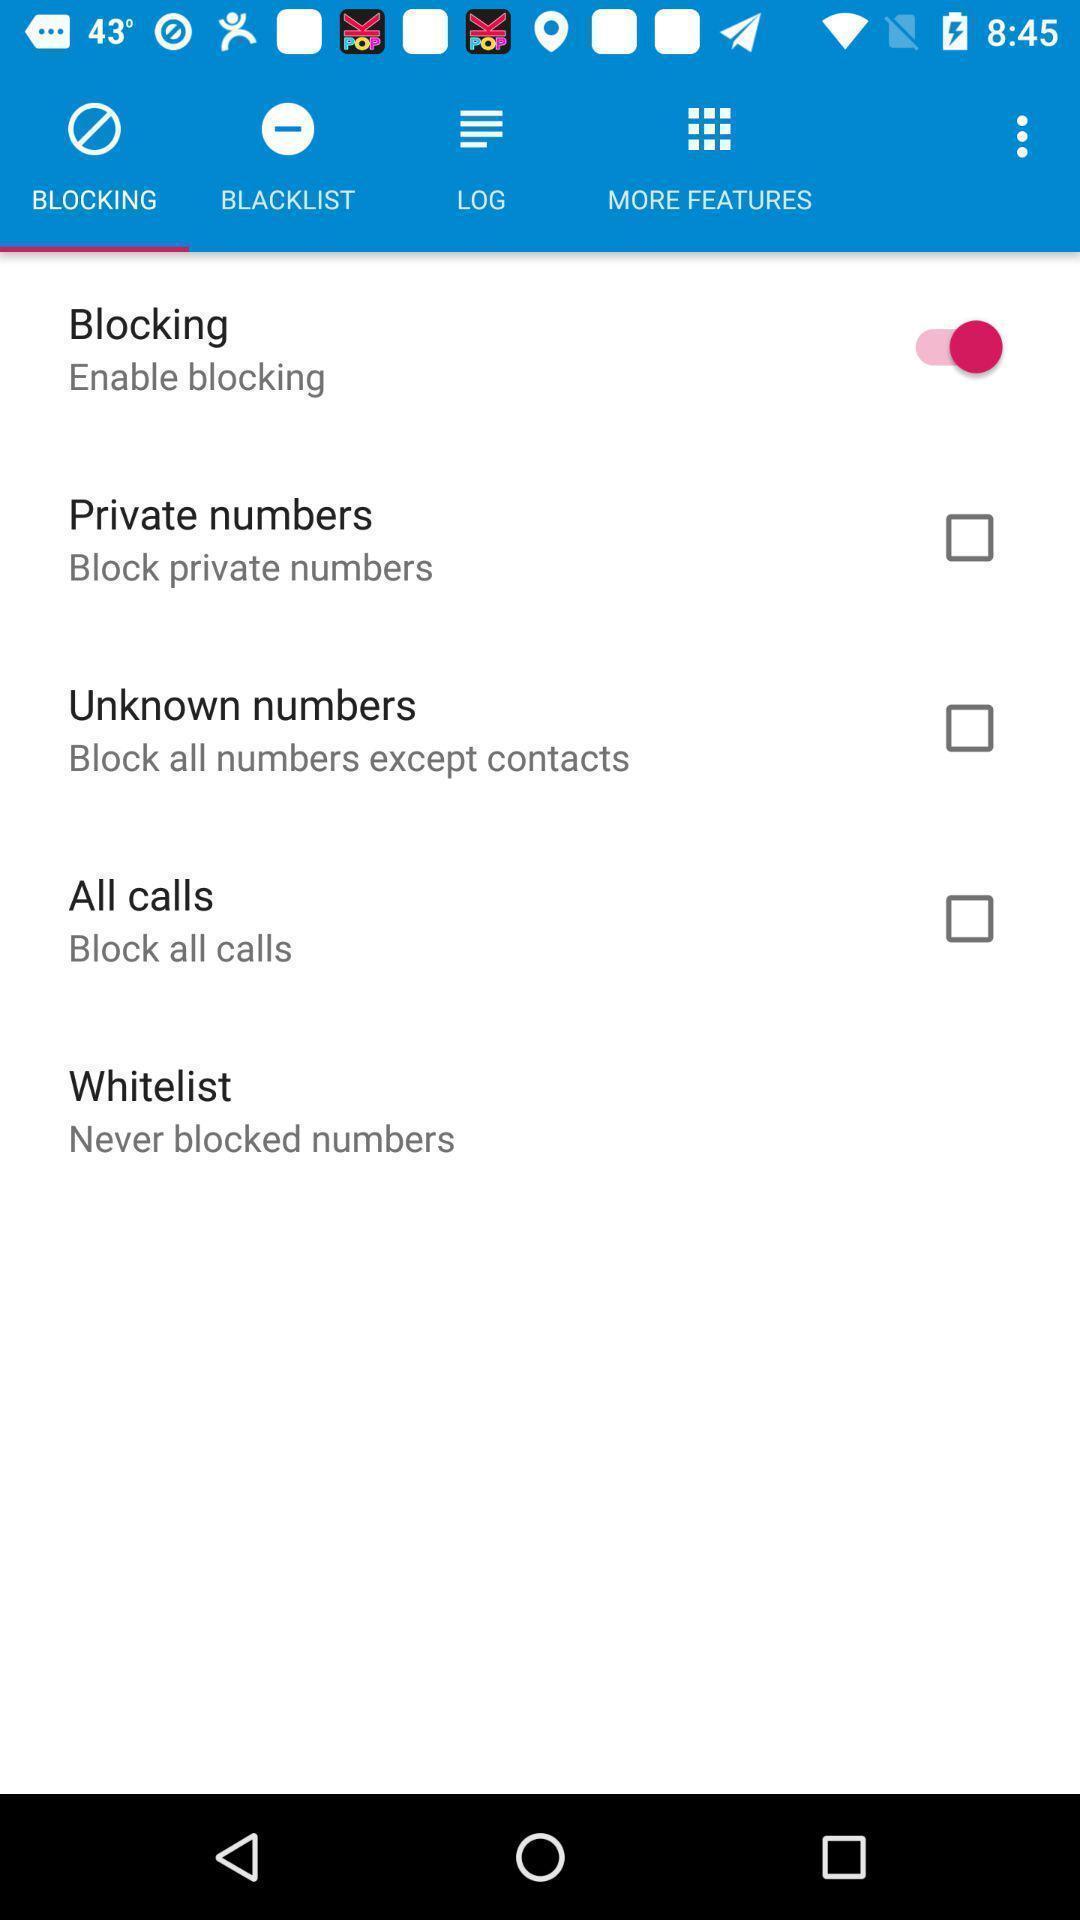Describe the key features of this screenshot. Screen page with different options in call application. 